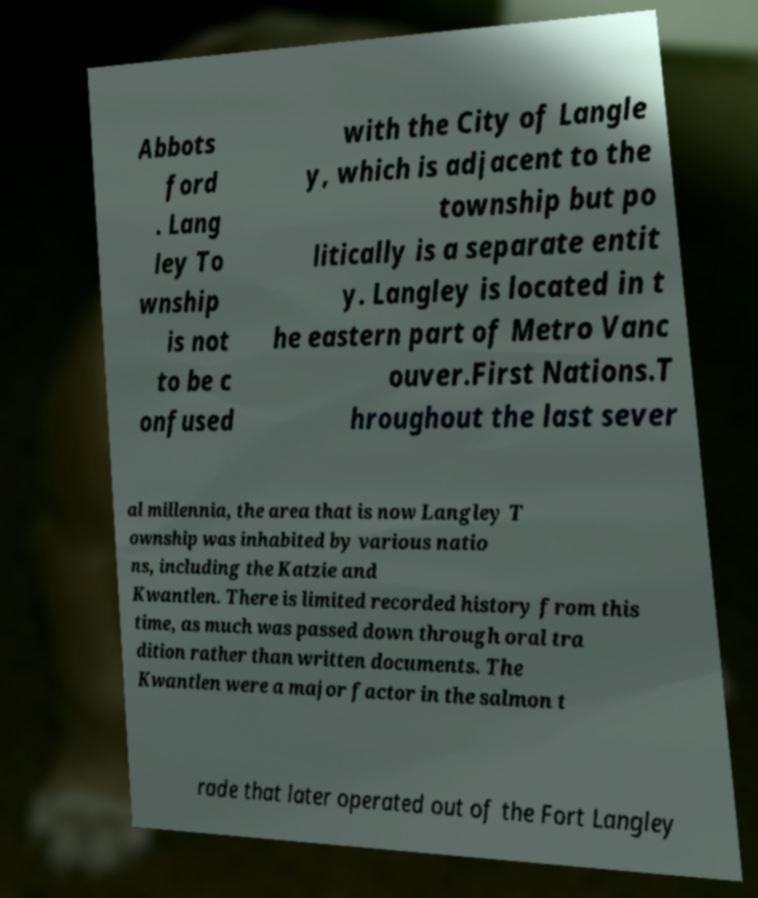Could you assist in decoding the text presented in this image and type it out clearly? Abbots ford . Lang ley To wnship is not to be c onfused with the City of Langle y, which is adjacent to the township but po litically is a separate entit y. Langley is located in t he eastern part of Metro Vanc ouver.First Nations.T hroughout the last sever al millennia, the area that is now Langley T ownship was inhabited by various natio ns, including the Katzie and Kwantlen. There is limited recorded history from this time, as much was passed down through oral tra dition rather than written documents. The Kwantlen were a major factor in the salmon t rade that later operated out of the Fort Langley 